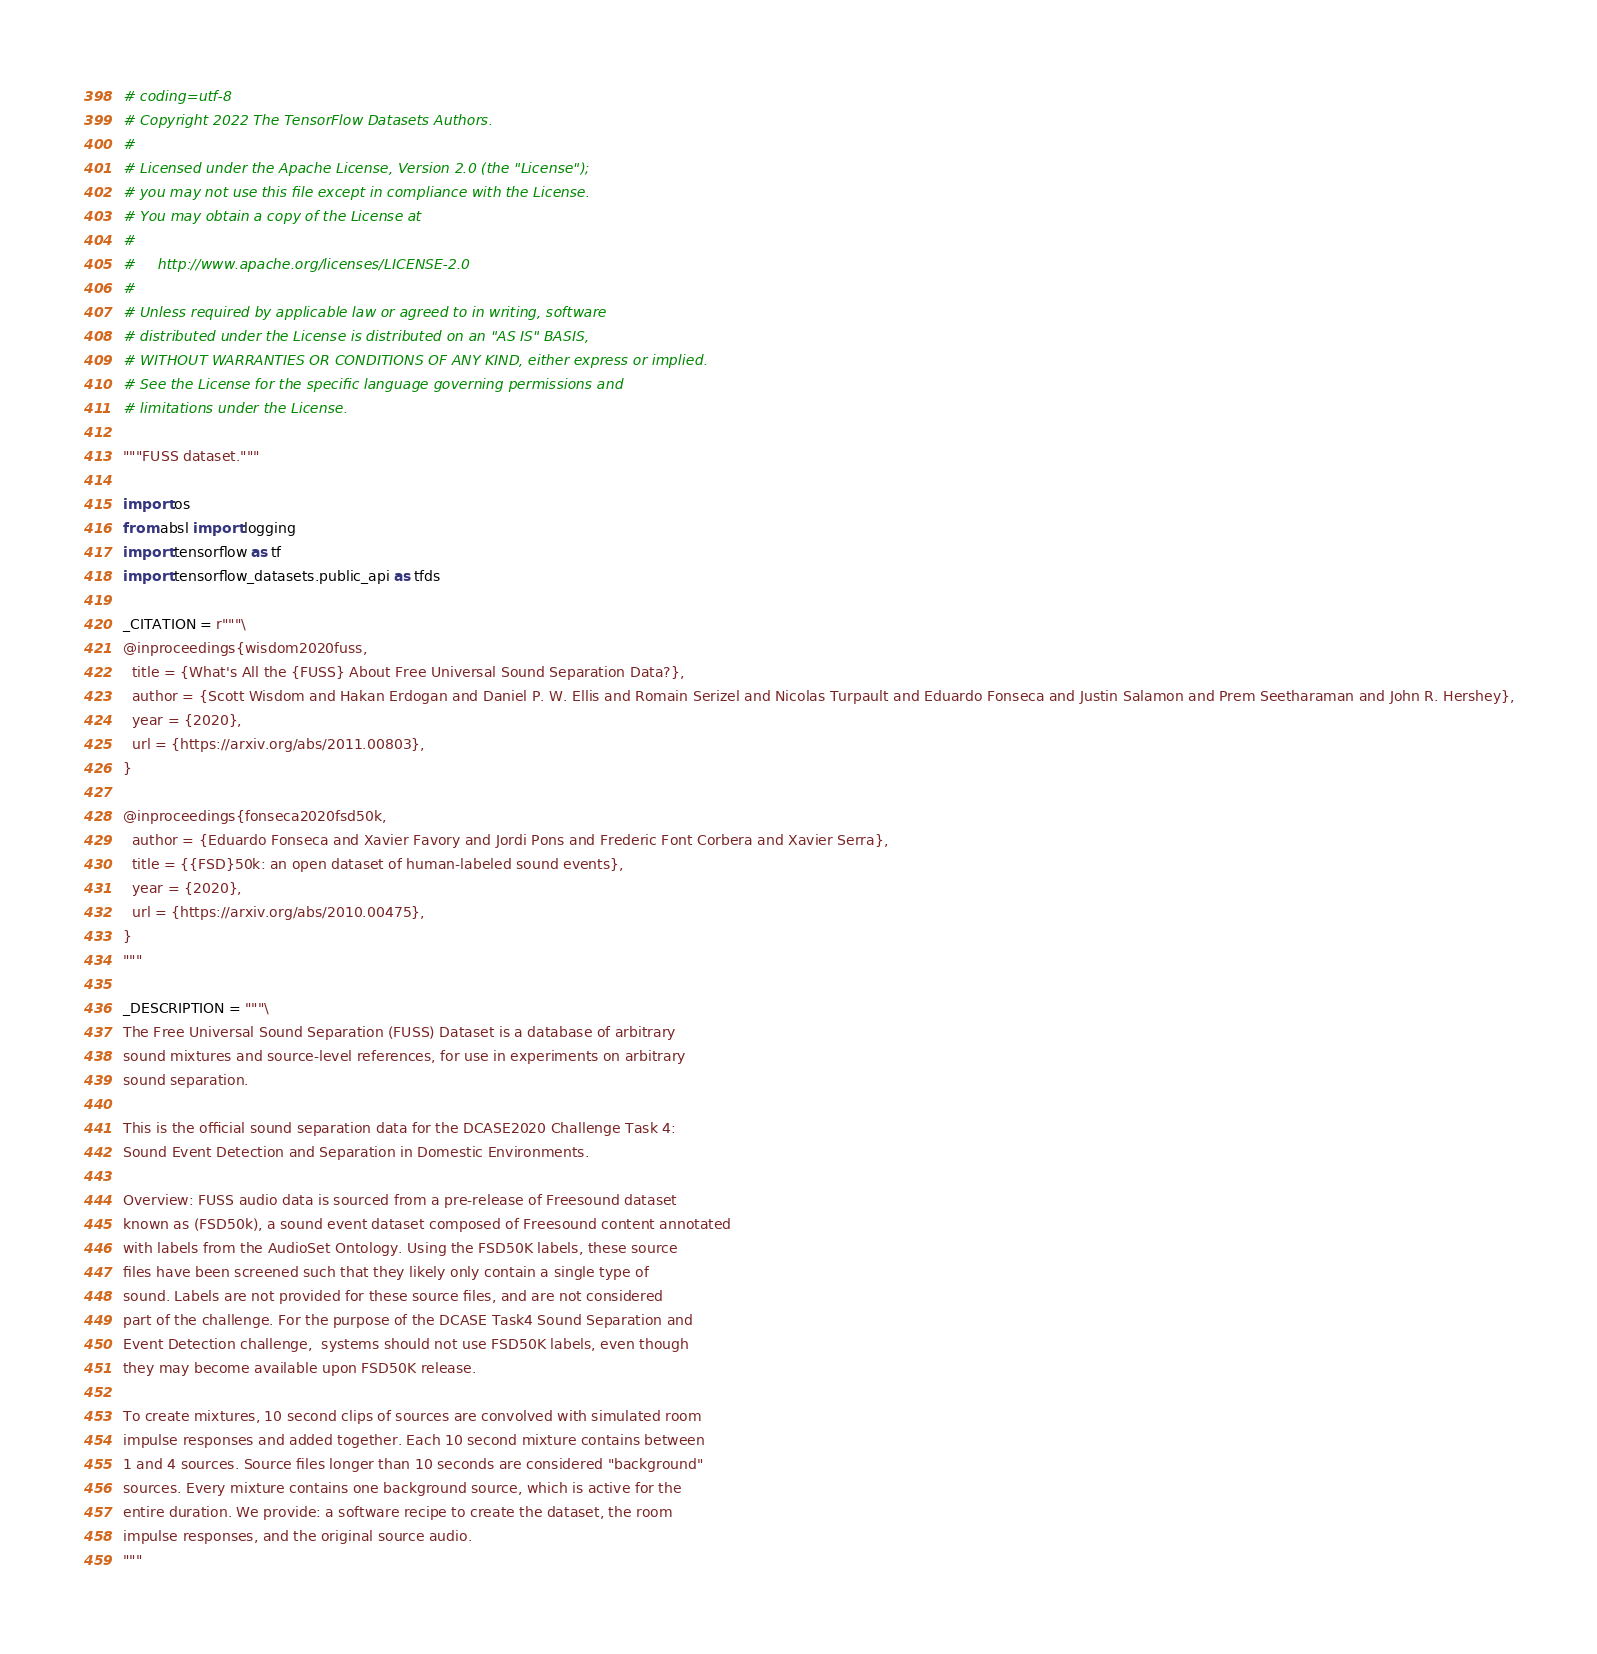Convert code to text. <code><loc_0><loc_0><loc_500><loc_500><_Python_># coding=utf-8
# Copyright 2022 The TensorFlow Datasets Authors.
#
# Licensed under the Apache License, Version 2.0 (the "License");
# you may not use this file except in compliance with the License.
# You may obtain a copy of the License at
#
#     http://www.apache.org/licenses/LICENSE-2.0
#
# Unless required by applicable law or agreed to in writing, software
# distributed under the License is distributed on an "AS IS" BASIS,
# WITHOUT WARRANTIES OR CONDITIONS OF ANY KIND, either express or implied.
# See the License for the specific language governing permissions and
# limitations under the License.

"""FUSS dataset."""

import os
from absl import logging
import tensorflow as tf
import tensorflow_datasets.public_api as tfds

_CITATION = r"""\
@inproceedings{wisdom2020fuss,
  title = {What's All the {FUSS} About Free Universal Sound Separation Data?},
  author = {Scott Wisdom and Hakan Erdogan and Daniel P. W. Ellis and Romain Serizel and Nicolas Turpault and Eduardo Fonseca and Justin Salamon and Prem Seetharaman and John R. Hershey},
  year = {2020},
  url = {https://arxiv.org/abs/2011.00803},
}

@inproceedings{fonseca2020fsd50k,
  author = {Eduardo Fonseca and Xavier Favory and Jordi Pons and Frederic Font Corbera and Xavier Serra},
  title = {{FSD}50k: an open dataset of human-labeled sound events},
  year = {2020},
  url = {https://arxiv.org/abs/2010.00475},
}
"""

_DESCRIPTION = """\
The Free Universal Sound Separation (FUSS) Dataset is a database of arbitrary
sound mixtures and source-level references, for use in experiments on arbitrary
sound separation.

This is the official sound separation data for the DCASE2020 Challenge Task 4:
Sound Event Detection and Separation in Domestic Environments.

Overview: FUSS audio data is sourced from a pre-release of Freesound dataset
known as (FSD50k), a sound event dataset composed of Freesound content annotated
with labels from the AudioSet Ontology. Using the FSD50K labels, these source
files have been screened such that they likely only contain a single type of
sound. Labels are not provided for these source files, and are not considered
part of the challenge. For the purpose of the DCASE Task4 Sound Separation and
Event Detection challenge,  systems should not use FSD50K labels, even though
they may become available upon FSD50K release.

To create mixtures, 10 second clips of sources are convolved with simulated room
impulse responses and added together. Each 10 second mixture contains between
1 and 4 sources. Source files longer than 10 seconds are considered "background"
sources. Every mixture contains one background source, which is active for the
entire duration. We provide: a software recipe to create the dataset, the room
impulse responses, and the original source audio.
"""
</code> 